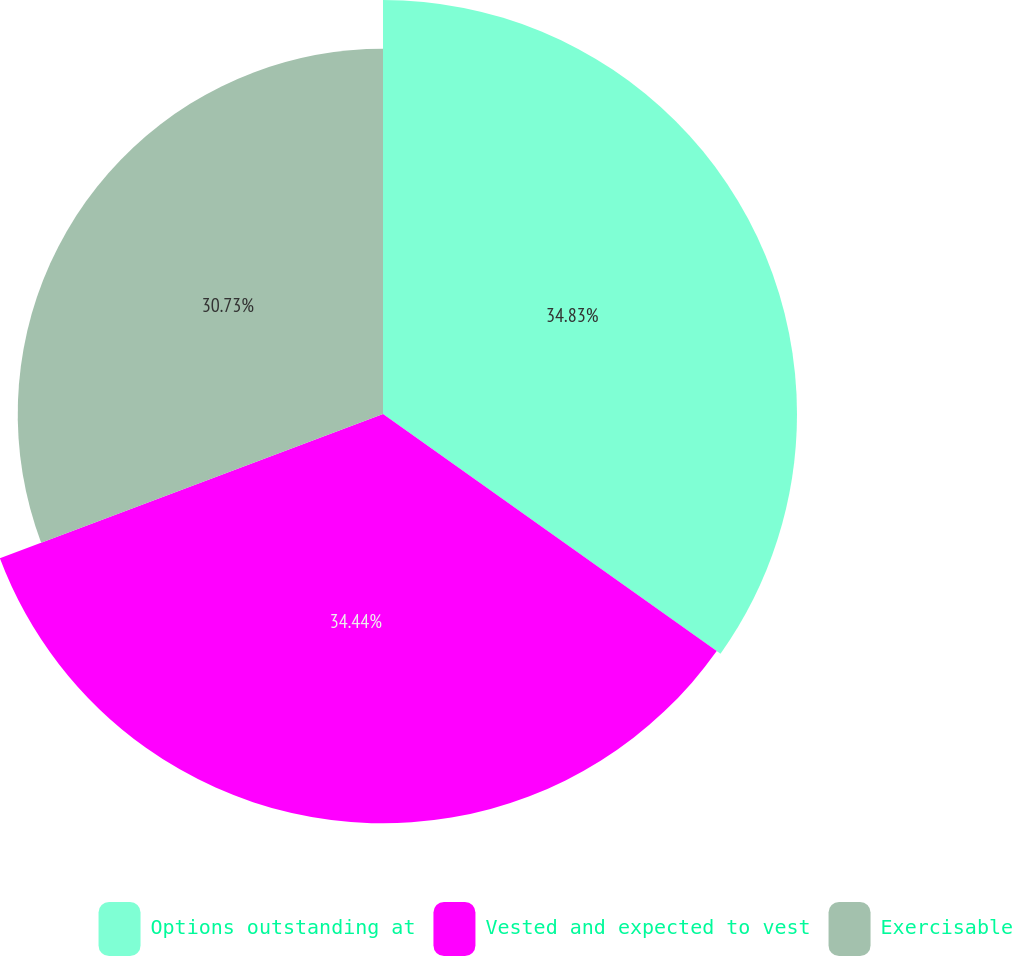Convert chart. <chart><loc_0><loc_0><loc_500><loc_500><pie_chart><fcel>Options outstanding at<fcel>Vested and expected to vest<fcel>Exercisable<nl><fcel>34.83%<fcel>34.44%<fcel>30.73%<nl></chart> 